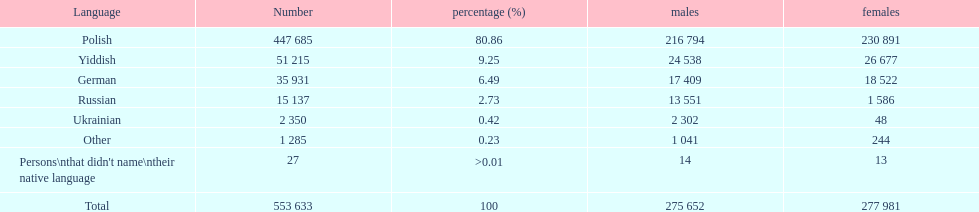42% of people as per the 1897 imperial census? Ukrainian. Would you be able to parse every entry in this table? {'header': ['Language', 'Number', 'percentage (%)', 'males', 'females'], 'rows': [['Polish', '447 685', '80.86', '216 794', '230 891'], ['Yiddish', '51 215', '9.25', '24 538', '26 677'], ['German', '35 931', '6.49', '17 409', '18 522'], ['Russian', '15 137', '2.73', '13 551', '1 586'], ['Ukrainian', '2 350', '0.42', '2 302', '48'], ['Other', '1 285', '0.23', '1 041', '244'], ["Persons\\nthat didn't name\\ntheir native language", '27', '>0.01', '14', '13'], ['Total', '553 633', '100', '275 652', '277 981']]} 